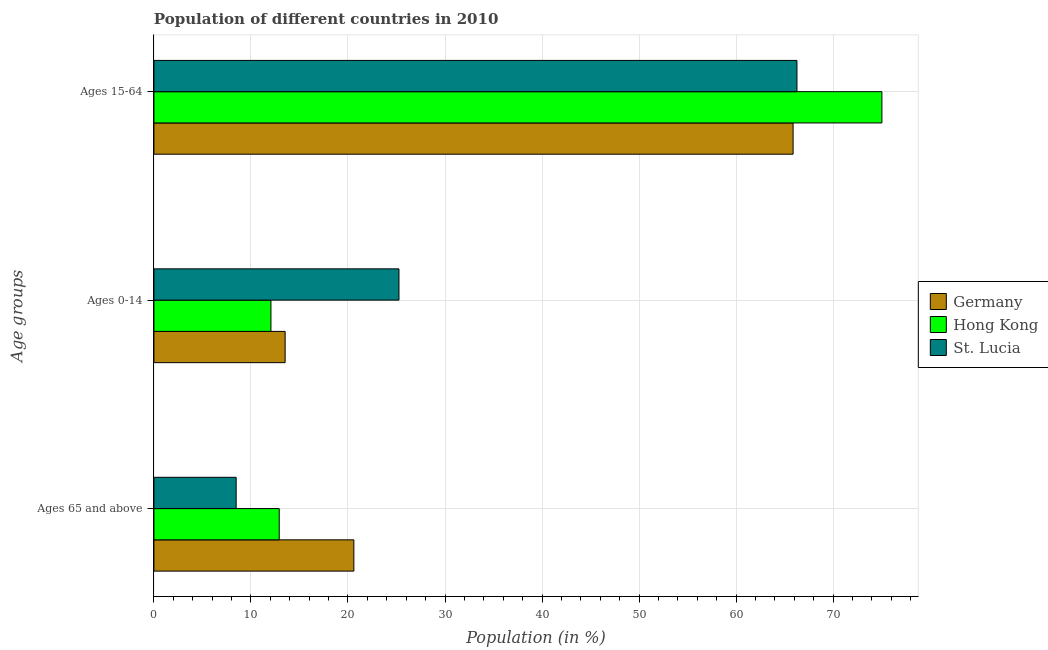Are the number of bars on each tick of the Y-axis equal?
Keep it short and to the point. Yes. How many bars are there on the 1st tick from the top?
Make the answer very short. 3. How many bars are there on the 1st tick from the bottom?
Your answer should be very brief. 3. What is the label of the 3rd group of bars from the top?
Ensure brevity in your answer.  Ages 65 and above. What is the percentage of population within the age-group 15-64 in Hong Kong?
Keep it short and to the point. 75.03. Across all countries, what is the maximum percentage of population within the age-group of 65 and above?
Provide a short and direct response. 20.6. Across all countries, what is the minimum percentage of population within the age-group 0-14?
Your answer should be compact. 12.06. In which country was the percentage of population within the age-group of 65 and above maximum?
Make the answer very short. Germany. What is the total percentage of population within the age-group of 65 and above in the graph?
Provide a succinct answer. 41.99. What is the difference between the percentage of population within the age-group 15-64 in St. Lucia and that in Hong Kong?
Give a very brief answer. -8.75. What is the difference between the percentage of population within the age-group 0-14 in Hong Kong and the percentage of population within the age-group 15-64 in St. Lucia?
Your response must be concise. -54.21. What is the average percentage of population within the age-group 15-64 per country?
Make the answer very short. 69.06. What is the difference between the percentage of population within the age-group 0-14 and percentage of population within the age-group of 65 and above in Germany?
Your response must be concise. -7.08. In how many countries, is the percentage of population within the age-group 0-14 greater than 62 %?
Your answer should be compact. 0. What is the ratio of the percentage of population within the age-group 0-14 in St. Lucia to that in Germany?
Your answer should be compact. 1.87. Is the percentage of population within the age-group 15-64 in Hong Kong less than that in St. Lucia?
Your response must be concise. No. Is the difference between the percentage of population within the age-group of 65 and above in St. Lucia and Hong Kong greater than the difference between the percentage of population within the age-group 0-14 in St. Lucia and Hong Kong?
Provide a short and direct response. No. What is the difference between the highest and the second highest percentage of population within the age-group of 65 and above?
Keep it short and to the point. 7.69. What is the difference between the highest and the lowest percentage of population within the age-group 0-14?
Keep it short and to the point. 13.19. Is the sum of the percentage of population within the age-group of 65 and above in Hong Kong and St. Lucia greater than the maximum percentage of population within the age-group 15-64 across all countries?
Make the answer very short. No. What does the 2nd bar from the bottom in Ages 65 and above represents?
Give a very brief answer. Hong Kong. How many bars are there?
Make the answer very short. 9. Are all the bars in the graph horizontal?
Provide a short and direct response. Yes. How many countries are there in the graph?
Offer a terse response. 3. Does the graph contain any zero values?
Offer a terse response. No. How are the legend labels stacked?
Offer a very short reply. Vertical. What is the title of the graph?
Your response must be concise. Population of different countries in 2010. Does "Malaysia" appear as one of the legend labels in the graph?
Your answer should be very brief. No. What is the label or title of the X-axis?
Your response must be concise. Population (in %). What is the label or title of the Y-axis?
Ensure brevity in your answer.  Age groups. What is the Population (in %) in Germany in Ages 65 and above?
Offer a very short reply. 20.6. What is the Population (in %) in Hong Kong in Ages 65 and above?
Keep it short and to the point. 12.91. What is the Population (in %) in St. Lucia in Ages 65 and above?
Offer a very short reply. 8.47. What is the Population (in %) of Germany in Ages 0-14?
Your answer should be very brief. 13.52. What is the Population (in %) in Hong Kong in Ages 0-14?
Give a very brief answer. 12.06. What is the Population (in %) of St. Lucia in Ages 0-14?
Make the answer very short. 25.25. What is the Population (in %) in Germany in Ages 15-64?
Provide a short and direct response. 65.87. What is the Population (in %) in Hong Kong in Ages 15-64?
Give a very brief answer. 75.03. What is the Population (in %) in St. Lucia in Ages 15-64?
Offer a terse response. 66.27. Across all Age groups, what is the maximum Population (in %) in Germany?
Make the answer very short. 65.87. Across all Age groups, what is the maximum Population (in %) of Hong Kong?
Ensure brevity in your answer.  75.03. Across all Age groups, what is the maximum Population (in %) in St. Lucia?
Give a very brief answer. 66.27. Across all Age groups, what is the minimum Population (in %) of Germany?
Your response must be concise. 13.52. Across all Age groups, what is the minimum Population (in %) in Hong Kong?
Offer a terse response. 12.06. Across all Age groups, what is the minimum Population (in %) of St. Lucia?
Give a very brief answer. 8.47. What is the total Population (in %) in Germany in the graph?
Provide a short and direct response. 100. What is the total Population (in %) in St. Lucia in the graph?
Your answer should be very brief. 100. What is the difference between the Population (in %) in Germany in Ages 65 and above and that in Ages 0-14?
Ensure brevity in your answer.  7.08. What is the difference between the Population (in %) in Hong Kong in Ages 65 and above and that in Ages 0-14?
Make the answer very short. 0.85. What is the difference between the Population (in %) in St. Lucia in Ages 65 and above and that in Ages 0-14?
Your answer should be compact. -16.78. What is the difference between the Population (in %) of Germany in Ages 65 and above and that in Ages 15-64?
Offer a very short reply. -45.27. What is the difference between the Population (in %) in Hong Kong in Ages 65 and above and that in Ages 15-64?
Keep it short and to the point. -62.11. What is the difference between the Population (in %) of St. Lucia in Ages 65 and above and that in Ages 15-64?
Your answer should be very brief. -57.8. What is the difference between the Population (in %) of Germany in Ages 0-14 and that in Ages 15-64?
Provide a succinct answer. -52.35. What is the difference between the Population (in %) of Hong Kong in Ages 0-14 and that in Ages 15-64?
Ensure brevity in your answer.  -62.97. What is the difference between the Population (in %) of St. Lucia in Ages 0-14 and that in Ages 15-64?
Your answer should be compact. -41.02. What is the difference between the Population (in %) of Germany in Ages 65 and above and the Population (in %) of Hong Kong in Ages 0-14?
Offer a terse response. 8.54. What is the difference between the Population (in %) in Germany in Ages 65 and above and the Population (in %) in St. Lucia in Ages 0-14?
Provide a succinct answer. -4.65. What is the difference between the Population (in %) in Hong Kong in Ages 65 and above and the Population (in %) in St. Lucia in Ages 0-14?
Offer a terse response. -12.34. What is the difference between the Population (in %) of Germany in Ages 65 and above and the Population (in %) of Hong Kong in Ages 15-64?
Your answer should be compact. -54.42. What is the difference between the Population (in %) of Germany in Ages 65 and above and the Population (in %) of St. Lucia in Ages 15-64?
Make the answer very short. -45.67. What is the difference between the Population (in %) in Hong Kong in Ages 65 and above and the Population (in %) in St. Lucia in Ages 15-64?
Offer a very short reply. -53.36. What is the difference between the Population (in %) of Germany in Ages 0-14 and the Population (in %) of Hong Kong in Ages 15-64?
Your response must be concise. -61.5. What is the difference between the Population (in %) in Germany in Ages 0-14 and the Population (in %) in St. Lucia in Ages 15-64?
Give a very brief answer. -52.75. What is the difference between the Population (in %) in Hong Kong in Ages 0-14 and the Population (in %) in St. Lucia in Ages 15-64?
Offer a very short reply. -54.21. What is the average Population (in %) of Germany per Age groups?
Provide a short and direct response. 33.33. What is the average Population (in %) in Hong Kong per Age groups?
Provide a succinct answer. 33.33. What is the average Population (in %) in St. Lucia per Age groups?
Make the answer very short. 33.33. What is the difference between the Population (in %) of Germany and Population (in %) of Hong Kong in Ages 65 and above?
Your answer should be compact. 7.69. What is the difference between the Population (in %) in Germany and Population (in %) in St. Lucia in Ages 65 and above?
Your answer should be very brief. 12.13. What is the difference between the Population (in %) in Hong Kong and Population (in %) in St. Lucia in Ages 65 and above?
Your response must be concise. 4.44. What is the difference between the Population (in %) of Germany and Population (in %) of Hong Kong in Ages 0-14?
Your response must be concise. 1.46. What is the difference between the Population (in %) of Germany and Population (in %) of St. Lucia in Ages 0-14?
Give a very brief answer. -11.73. What is the difference between the Population (in %) of Hong Kong and Population (in %) of St. Lucia in Ages 0-14?
Offer a very short reply. -13.19. What is the difference between the Population (in %) in Germany and Population (in %) in Hong Kong in Ages 15-64?
Keep it short and to the point. -9.15. What is the difference between the Population (in %) in Germany and Population (in %) in St. Lucia in Ages 15-64?
Your answer should be compact. -0.4. What is the difference between the Population (in %) of Hong Kong and Population (in %) of St. Lucia in Ages 15-64?
Your answer should be very brief. 8.75. What is the ratio of the Population (in %) of Germany in Ages 65 and above to that in Ages 0-14?
Your answer should be very brief. 1.52. What is the ratio of the Population (in %) of Hong Kong in Ages 65 and above to that in Ages 0-14?
Your answer should be very brief. 1.07. What is the ratio of the Population (in %) of St. Lucia in Ages 65 and above to that in Ages 0-14?
Your response must be concise. 0.34. What is the ratio of the Population (in %) of Germany in Ages 65 and above to that in Ages 15-64?
Your answer should be very brief. 0.31. What is the ratio of the Population (in %) in Hong Kong in Ages 65 and above to that in Ages 15-64?
Give a very brief answer. 0.17. What is the ratio of the Population (in %) of St. Lucia in Ages 65 and above to that in Ages 15-64?
Make the answer very short. 0.13. What is the ratio of the Population (in %) of Germany in Ages 0-14 to that in Ages 15-64?
Offer a terse response. 0.21. What is the ratio of the Population (in %) in Hong Kong in Ages 0-14 to that in Ages 15-64?
Keep it short and to the point. 0.16. What is the ratio of the Population (in %) of St. Lucia in Ages 0-14 to that in Ages 15-64?
Keep it short and to the point. 0.38. What is the difference between the highest and the second highest Population (in %) in Germany?
Provide a short and direct response. 45.27. What is the difference between the highest and the second highest Population (in %) of Hong Kong?
Provide a short and direct response. 62.11. What is the difference between the highest and the second highest Population (in %) of St. Lucia?
Offer a terse response. 41.02. What is the difference between the highest and the lowest Population (in %) in Germany?
Offer a very short reply. 52.35. What is the difference between the highest and the lowest Population (in %) in Hong Kong?
Your response must be concise. 62.97. What is the difference between the highest and the lowest Population (in %) in St. Lucia?
Offer a terse response. 57.8. 